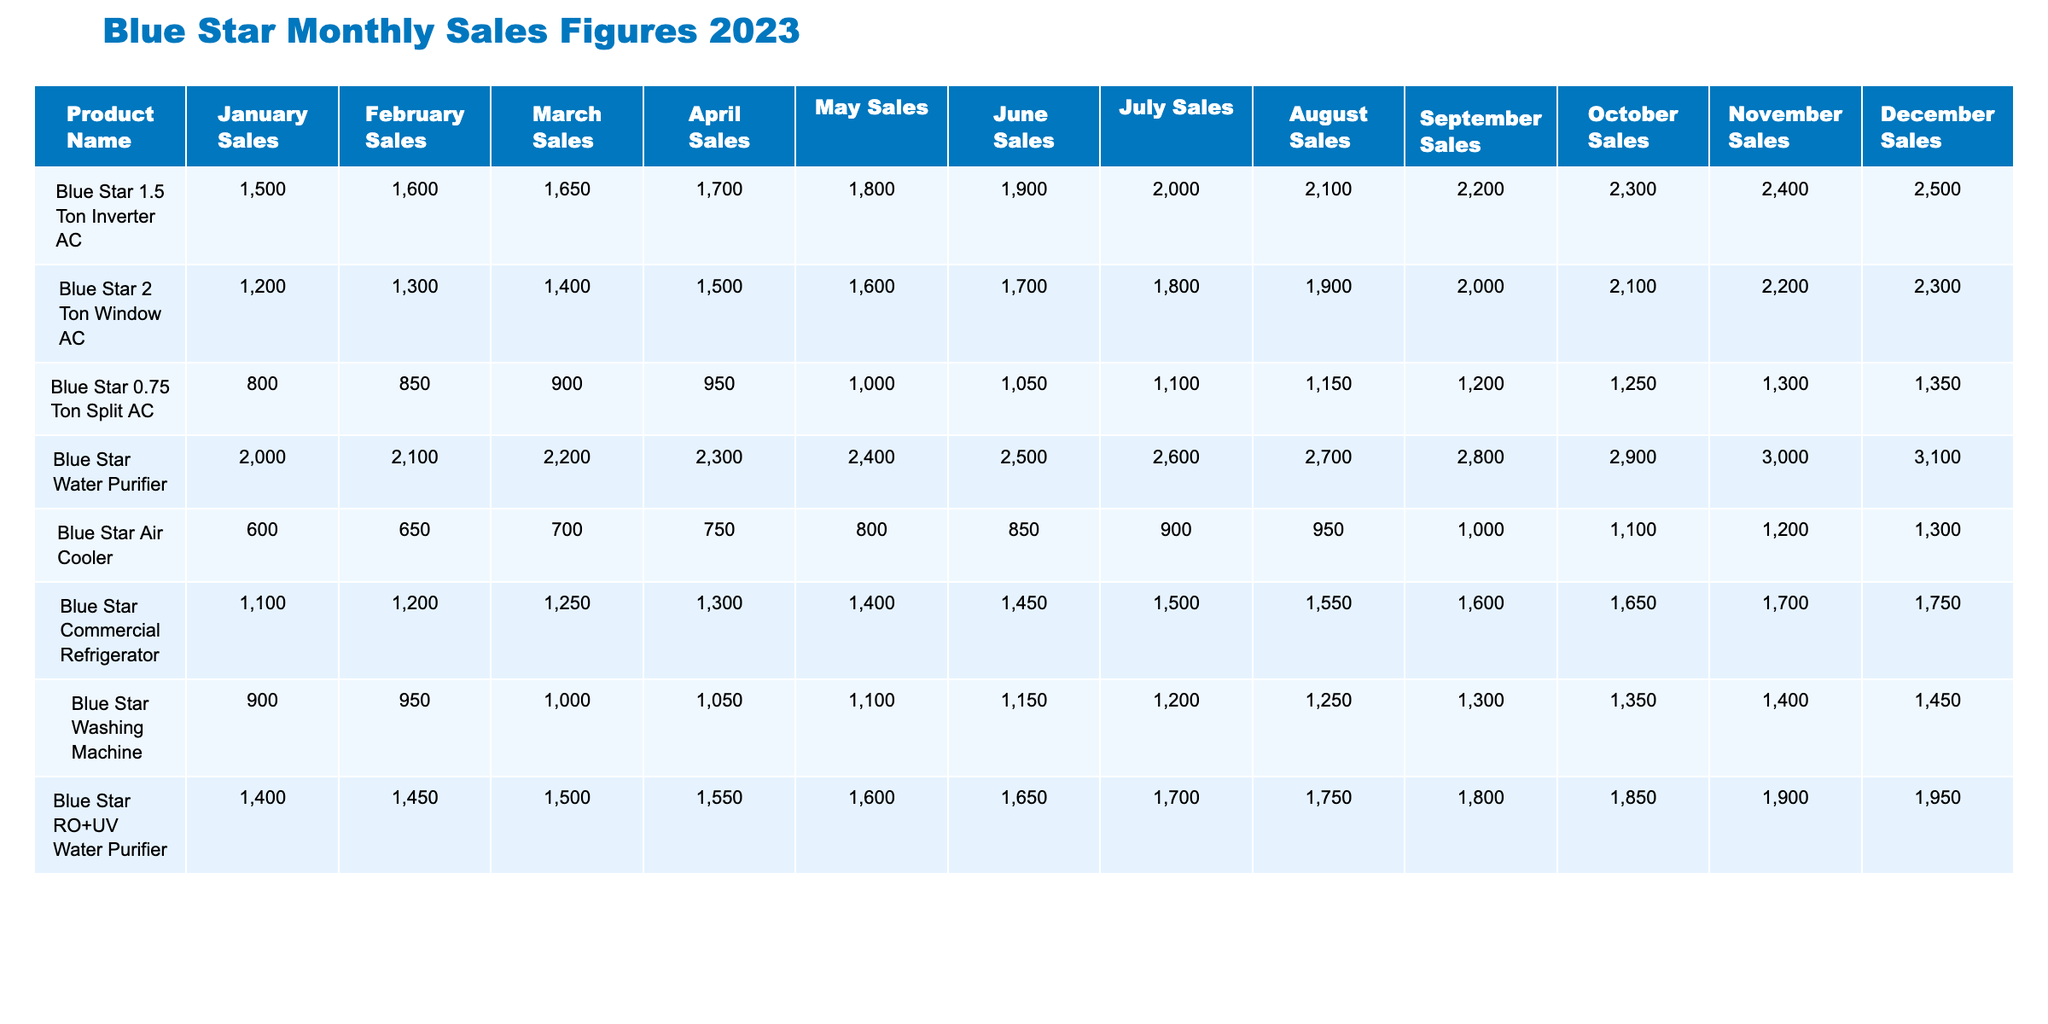What was the highest sales figure for the Blue Star Water Purifier in 2023? The highest sales figure for the Blue Star Water Purifier can be found by looking at the sales in December. The figure is 3100.
Answer: 3100 Which product had the lowest sales in January? By examining the January sales column, the lowest sales figure is 600, which belongs to the Blue Star Air Cooler.
Answer: Blue Star Air Cooler What is the total sales figure for the Blue Star 2 Ton Window AC from January to June? To find the total, add the monthly sales figures from January to June: 1200 + 1300 + 1400 + 1500 + 1600 + 1700 = 10200.
Answer: 10200 Did the sales of the Blue Star 1.5 Ton Inverter AC increase in every month from January to December? By checking each month from January to December, it's clear that the sales figure consistently increases, confirming a continuous rise throughout the year.
Answer: Yes What is the average monthly sales figure for the Blue Star Commercial Refrigerator in 2023? To calculate the average, sum up the sales figures for all twelve months: 1100 + 1200 + 1250 + 1300 + 1400 + 1450 + 1500 + 1550 + 1600 + 1650 + 1700 + 1750 = 17100, then divide by 12 to get an average of 1425.
Answer: 1425 Which product had the highest sales in July, and what was the figure? The table indicates that the Blue Star Water Purifier had the highest sales in July with a total of 2600.
Answer: Blue Star Water Purifier, 2600 What are the total sales figures for Blue Star Washing Machine and Blue Star RO+UV Water Purifier combined in 2023? To find the total, add both products' monthly sales figures: Blue Star Washing Machine = 900 + 950 + 1000 + 1050 + 1100 + 1150 + 1200 + 1250 + 1300 + 1350 + 1400 + 1450 = 13900; Blue Star RO+UV Water Purifier = 1400 + 1450 + 1500 + 1550 + 1600 + 1650 + 1700 + 1750 + 1800 + 1850 + 1900 + 1950 = 19400. Then 13900 + 19400 = 33300.
Answer: 33300 Was the sales figure for the Blue Star Air Cooler in December higher or lower than that of the Blue Star Washing Machine? The sales figure for the Blue Star Air Cooler in December was 1300, whereas the Blue Star Washing Machine had a sales figure of 1450. Thus, the Air Cooler had lower sales.
Answer: Lower What is the month with the biggest sales increase for the Blue Star 0.75 Ton Split AC, and what is the increase? By examining the sales figures month over month, the most significant increase occurs from March to April, where sales rose from 900 to 950, an increase of 50.
Answer: April, 50 What are the monthly sales figures for the Blue Star Water Purifier for the first half of 2023, and how do they compare to the second half? The sales figures for January to June are 2000, 2100, 2200, 2300, 2400, and 2500, which sum to 12600. For July to December, the figures are 2600, 2700, 2800, 2900, 3000, and 3100, totaling 16800. Thus, the second half is higher by 4200.
Answer: First half: 12600, second half: 16800, difference: 4200 